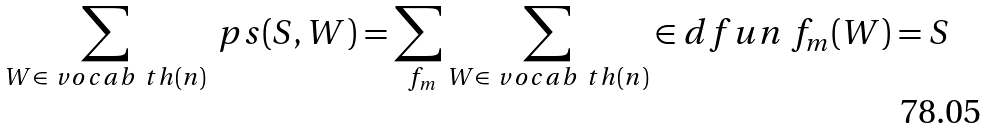<formula> <loc_0><loc_0><loc_500><loc_500>\sum _ { W \in \ v o c a b { \ t h } ( n ) } \ p s ( S , W ) = \sum _ { \ f _ { m } } \sum _ { W \in \ v o c a b { \ t h } ( n ) } \in d f u n { \ f _ { m } ( W ) = S }</formula> 